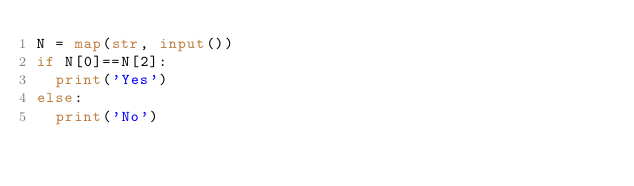<code> <loc_0><loc_0><loc_500><loc_500><_Python_>N = map(str, input())
if N[0]==N[2]:
  print('Yes')
else:
  print('No')</code> 